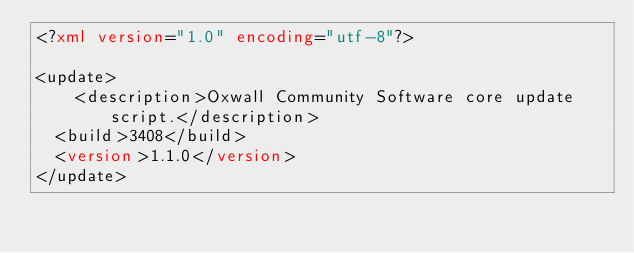<code> <loc_0><loc_0><loc_500><loc_500><_XML_><?xml version="1.0" encoding="utf-8"?>

<update>
    <description>Oxwall Community Software core update script.</description>
	<build>3408</build>
	<version>1.1.0</version>
</update>
</code> 